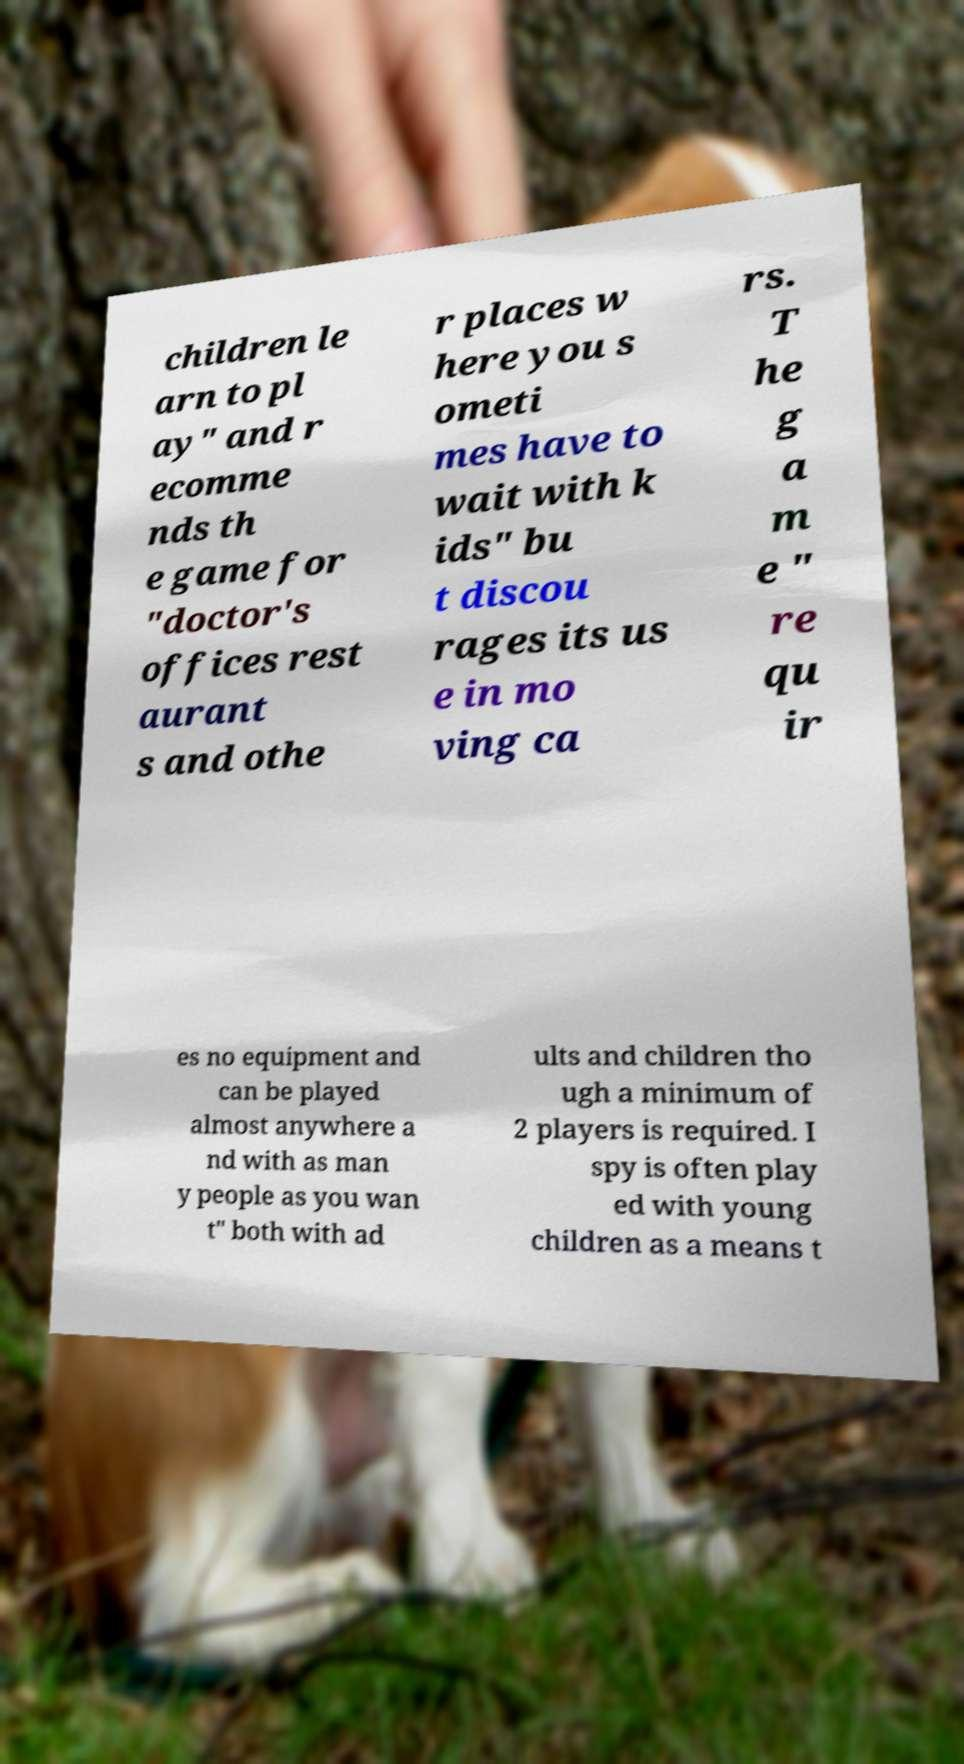Please identify and transcribe the text found in this image. children le arn to pl ay" and r ecomme nds th e game for "doctor's offices rest aurant s and othe r places w here you s ometi mes have to wait with k ids" bu t discou rages its us e in mo ving ca rs. T he g a m e " re qu ir es no equipment and can be played almost anywhere a nd with as man y people as you wan t" both with ad ults and children tho ugh a minimum of 2 players is required. I spy is often play ed with young children as a means t 